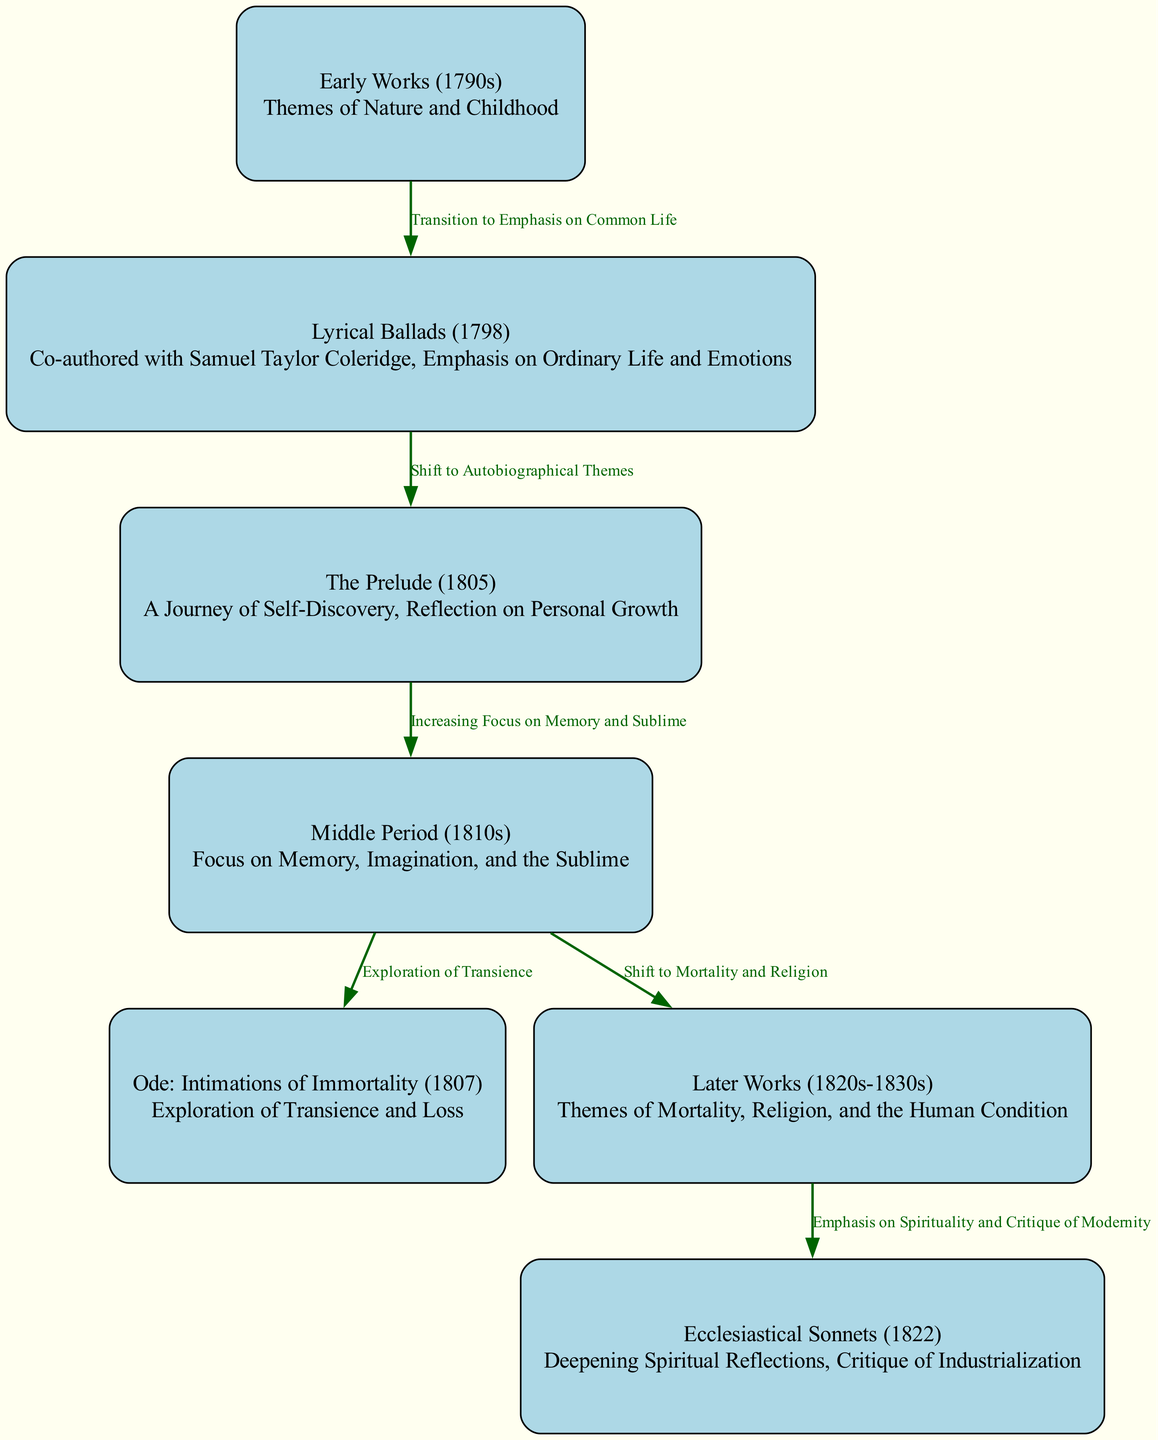What themes are present in Early Works? According to the diagram, the node labeled "Early Works (1790s)" describes themes of Nature and Childhood, which can be directly found in its description.
Answer: Nature and Childhood What does the edge label between Lyrical Ballads and The Prelude indicate? The edge label connecting "Lyrical Ballads" to "The Prelude" is "Shift to Autobiographical Themes," which suggests a thematic transition reflected in Wordsworth's works.
Answer: Shift to Autobiographical Themes How many total nodes are represented in the diagram? By counting the nodes listed in the diagram, there are seven nodes, including the main categories of Wordsworth's works presented.
Answer: 7 What is the primary focus of Middle Period works? The "Middle Period (1810s)" node indicates a focus on Memory, Imagination, and the Sublime, which is explicitly stated in its description.
Answer: Memory, Imagination, and the Sublime What significant change occurs from the Middle Period to Later Works? The transition indicated by the edge between "Middle Period" and "Later Works" signifies a "Shift to Mortality and Religion," showing a change in thematic focus.
Answer: Shift to Mortality and Religion How are the themes of Later Works characterized? The node labeled "Later Works (1820s-1830s)" illustrates themes revolving around Mortality, Religion, and the Human Condition, which clearly articulates the focus of that period.
Answer: Mortality, Religion, and the Human Condition What do the Ecclesiastical Sonnets emphasize? The description for "Ecclesiastical Sonnets (1822)" states a focus on Deepening Spiritual Reflections and a Critique of Industrialization, conveying its primary themes.
Answer: Deepening Spiritual Reflections and Critique of Industrialization What relationship is indicated by the connection between Ode: Intimations of Immortality and Middle Period? The edge label between "Ode: Intimations of Immortality" and "Middle Period" says "Exploration of Transience," indicating that this exploration is a thematic continuation from the Middle Period works.
Answer: Exploration of Transience What kind of relationship do the Later Works have with Ecclesiastical Sonnets? According to the diagram, the edge between "Later Works" and "Ecclesiastical Sonnets" shows an emphasis on Spirituality and Critique of Modernity, highlighting the thematic connection.
Answer: Emphasis on Spirituality and Critique of Modernity 